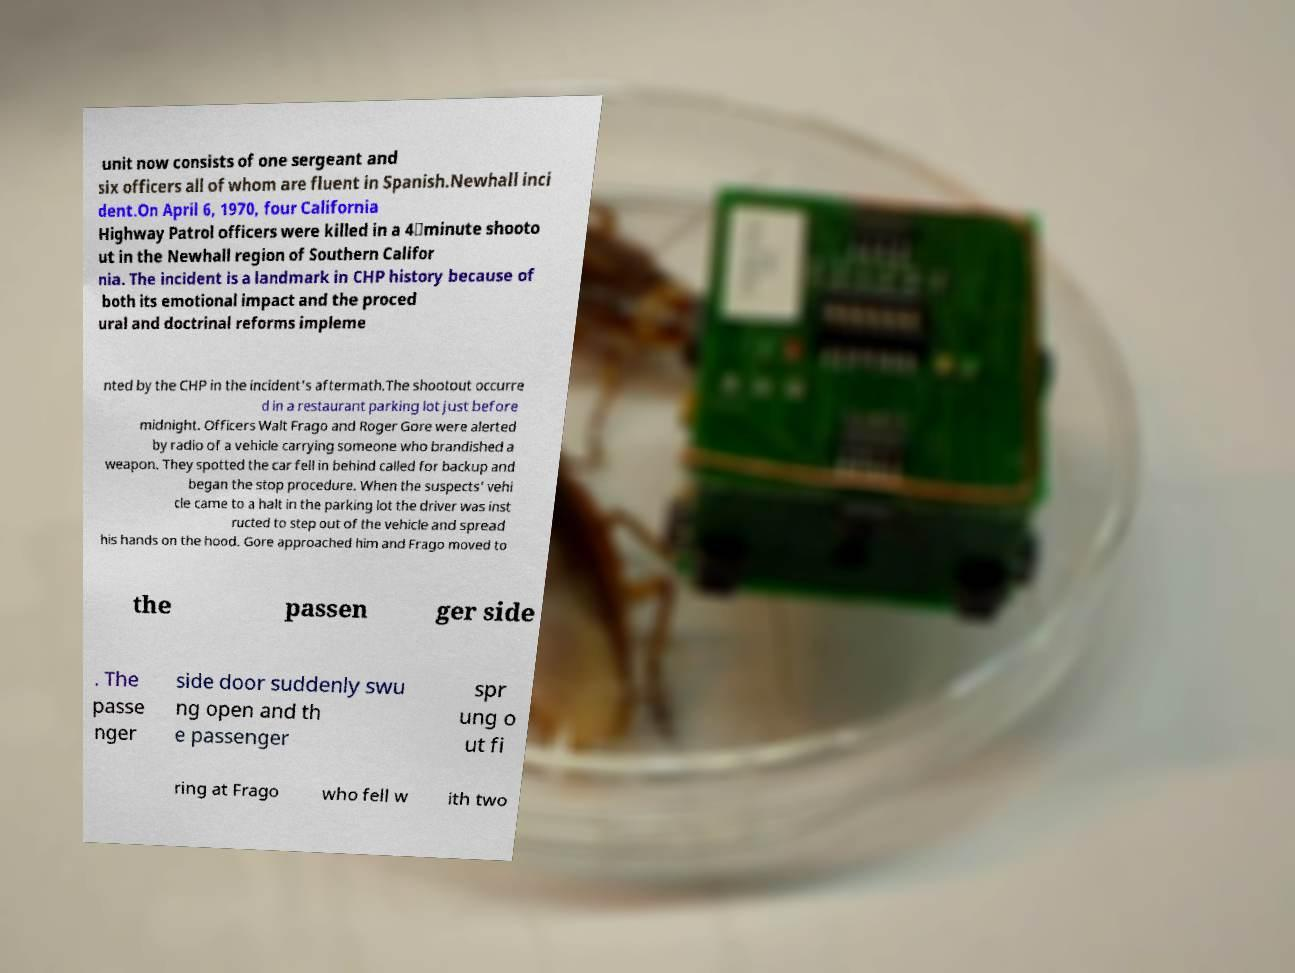Please identify and transcribe the text found in this image. unit now consists of one sergeant and six officers all of whom are fluent in Spanish.Newhall inci dent.On April 6, 1970, four California Highway Patrol officers were killed in a 4‑minute shooto ut in the Newhall region of Southern Califor nia. The incident is a landmark in CHP history because of both its emotional impact and the proced ural and doctrinal reforms impleme nted by the CHP in the incident's aftermath.The shootout occurre d in a restaurant parking lot just before midnight. Officers Walt Frago and Roger Gore were alerted by radio of a vehicle carrying someone who brandished a weapon. They spotted the car fell in behind called for backup and began the stop procedure. When the suspects' vehi cle came to a halt in the parking lot the driver was inst ructed to step out of the vehicle and spread his hands on the hood. Gore approached him and Frago moved to the passen ger side . The passe nger side door suddenly swu ng open and th e passenger spr ung o ut fi ring at Frago who fell w ith two 